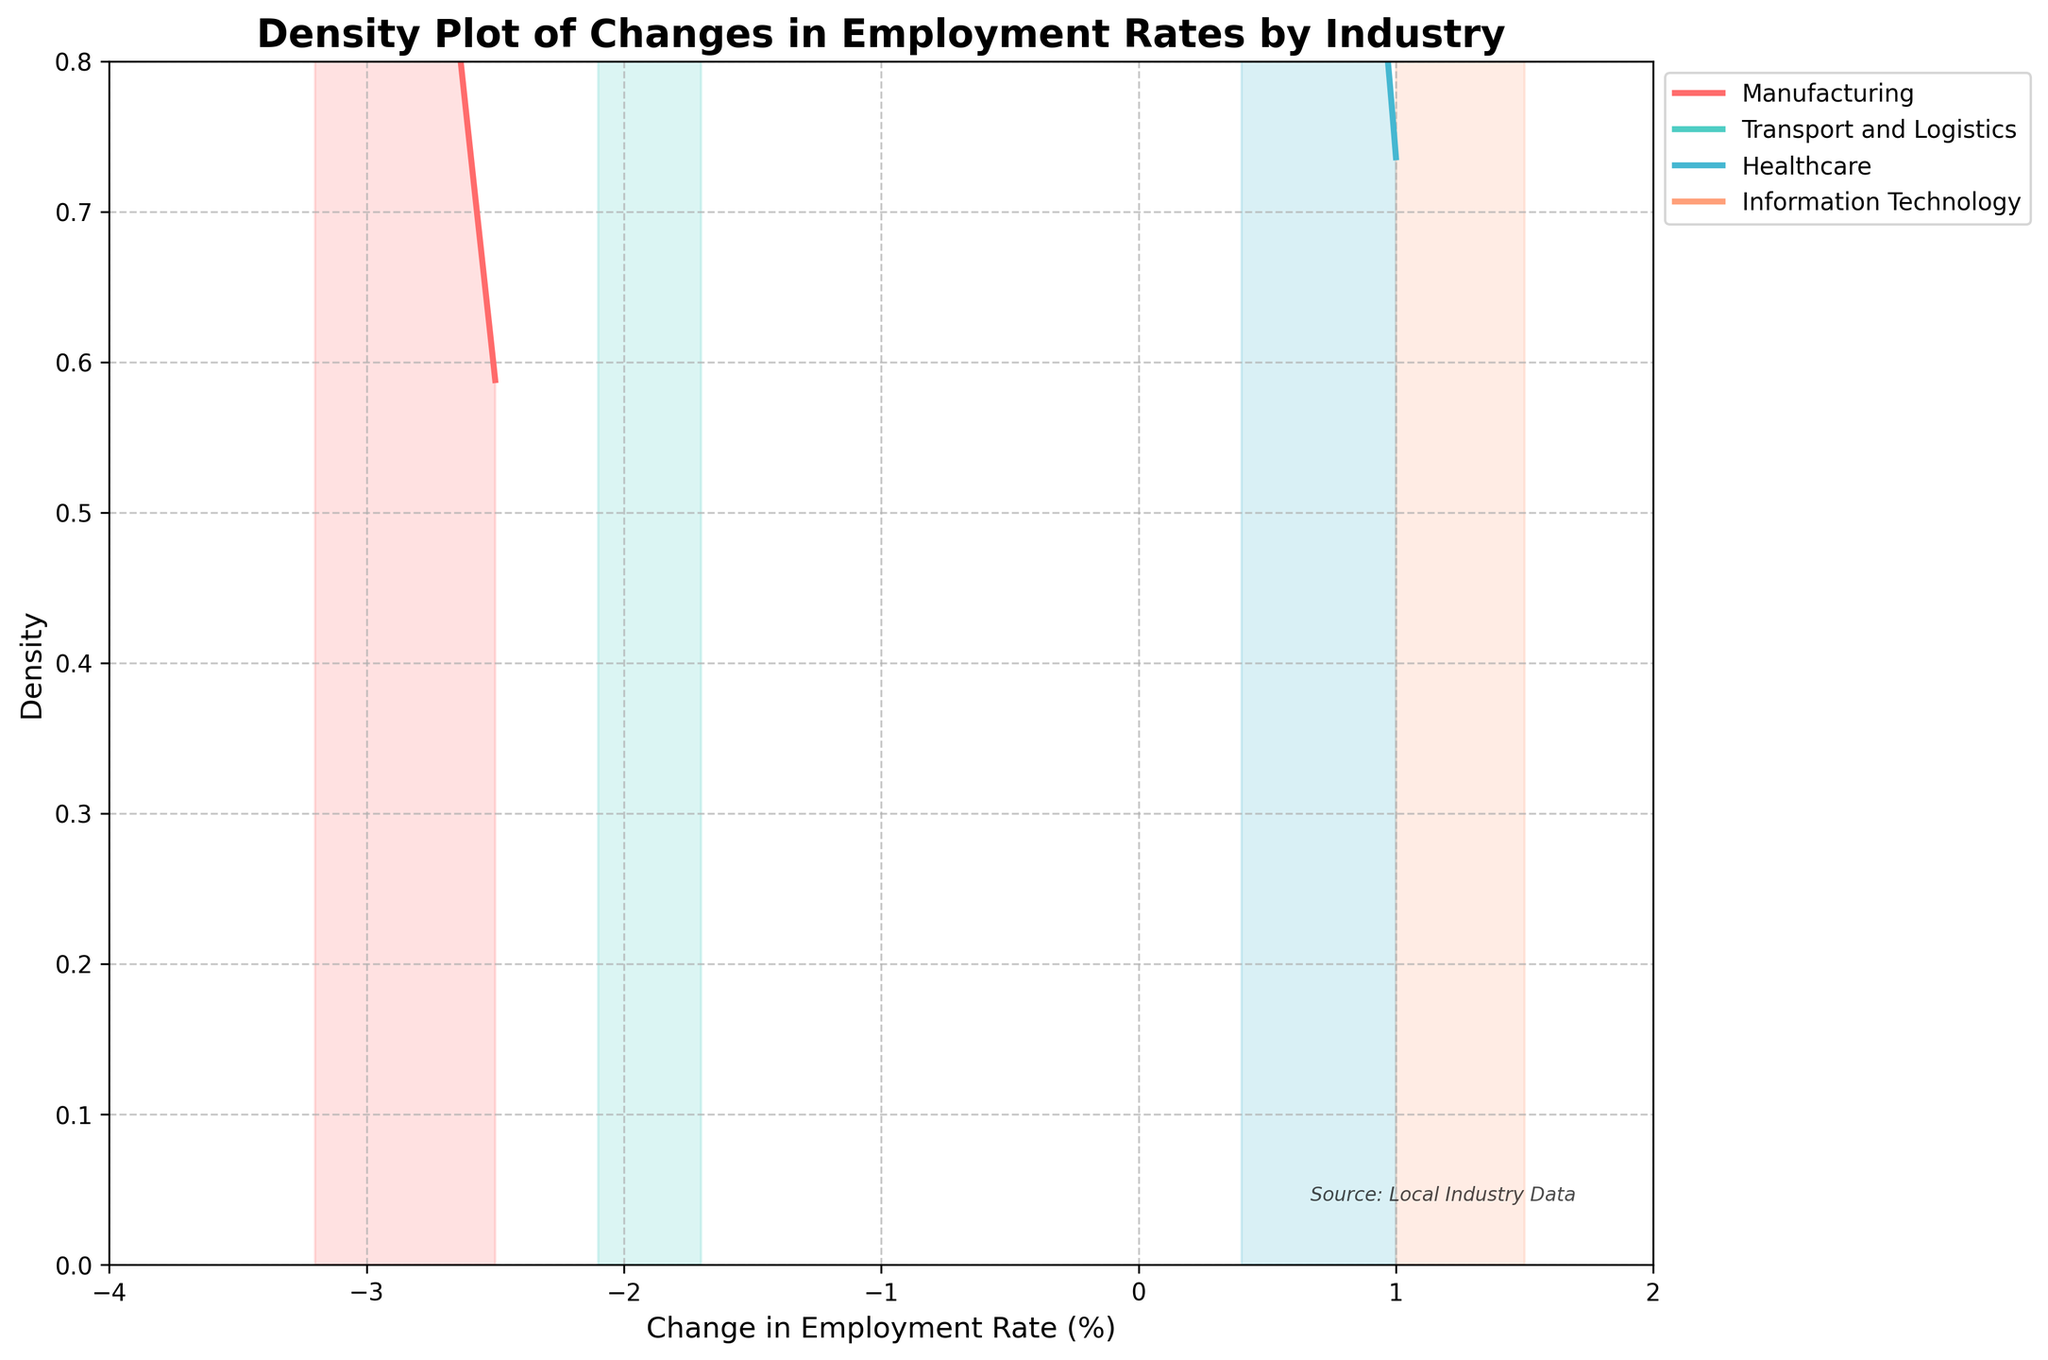What is the title of the plot? The title of the plot is written at the top and is "Density Plot of Changes in Employment Rates by Industry".
Answer: Density Plot of Changes in Employment Rates by Industry What is the range of the x-axis? The x-axis range can be seen from the plot where it starts at -4 and ends at 2, indicating the range of the change in employment rates (%) shown on the x-axis.
Answer: -4 to 2 Which industry shows the steepest decline in employment rates? Look at the denseness and peak of the curves, focusing on the part showing negative values. Manufacturing has the most prominent peak on the negative side, indicating the steepest decline.
Answer: Manufacturing Which industry has the least change in employment rates? The curves for Healthcare and Information Technology are mostly above zero and closer to zero, indicating smaller changes. Among these, Healthcare has a minimal change as its curve is closest to zero.
Answer: Healthcare What is the peak density value for 'Transport and Logistics'? Look at the highest point of the curve for 'Transport and Logistics', which is colored in the plot. The peak is approximately at 0.5 on the y-axis.
Answer: ~0.5 Between which values does the 'Information Technology' range lie on the x-axis? Observe the start and end points of the curve representing 'Information Technology' on the x-axis. It ranges approximately from -0.5 to 1.5.
Answer: -0.5 to 1.5 Which industry has a peak density above 0.7? Looking at the y-axis and the highest point for each density curve, Manufacturing has a peak density exceeding 0.7.
Answer: Manufacturing What is the color used to represent the 'Healthcare' industry? Refer to the legend on the plot. The color used for Healthcare is noted and can be identified in the plot.
Answer: Light Blue/Teal Which industry has the broadest spread of change in employment rates? The width of the curve indicates the spread. 'Information Technology' has the broadest spread as its density curve covers the most extended range on the x-axis.
Answer: Information Technology 